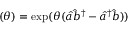Convert formula to latex. <formula><loc_0><loc_0><loc_500><loc_500>( \theta ) = \exp ( \theta ( \hat { a } \hat { b } ^ { \dagger } - \hat { a } ^ { \dagger } \hat { b } ) )</formula> 